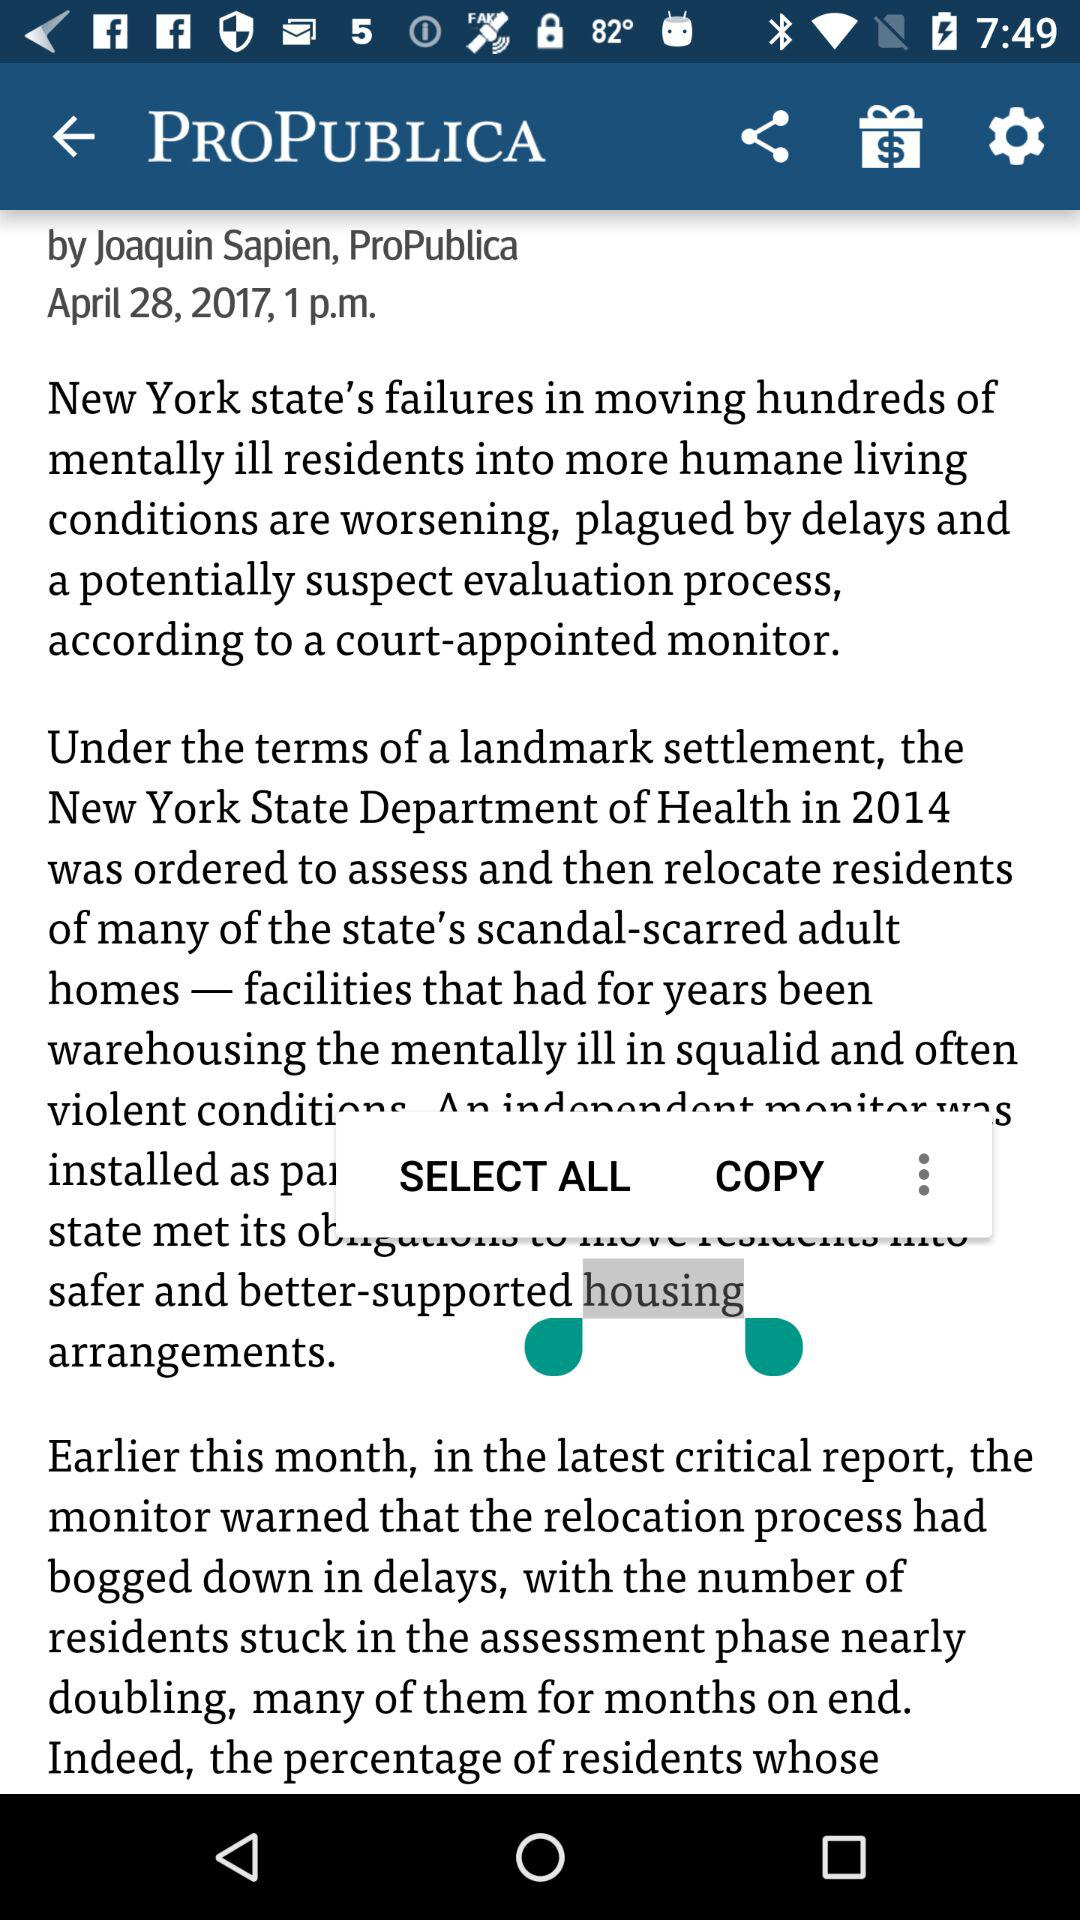When was the article posted? The article was posted on April 28, 2017 at 1 p.m. 